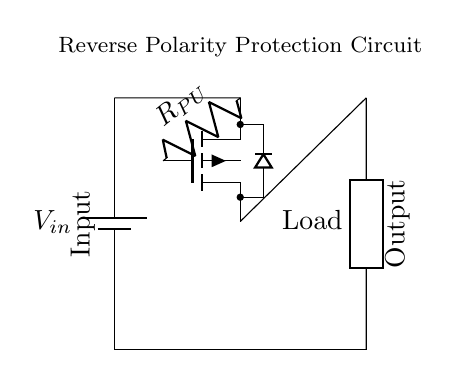What type of MOSFET is used in this circuit? The circuit diagram contains a P-channel MOSFET as indicated by the symbol shown, which has the gate labeled and is connected from the source to the load.
Answer: P-channel MOSFET What does the resistor in the circuit represent? The resistor labeled R_PU is a pull-up resistor used to ensure that the MOSFET is turned off when V_in is at or near zero volts, preventing undesired operation of the circuit.
Answer: Pull-up resistor What is the function of this reverse polarity protection circuit? The circuit protects the load from being damaged by reverse polarity conditions by using the P-channel MOSFET to block the current when the voltage is reversed.
Answer: Protects against reverse polarity What is the configuration of the load in the circuit? The load is represented as a generic component connected to the output of the P-channel MOSFET, effectively receiving power when the MOSFET is conducting.
Answer: Generic load How does the circuit behave when V_in is negative? When V_in is negative, the P-channel MOSFET will turn off, preventing current flow to the load and protecting it from reverse polarity damage.
Answer: No current flow What happens to the P-channel MOSFET when V_in is applied correctly? When V_in is applied in the correct polarity, the gate voltage becomes lower than the source voltage, turning the P-channel MOSFET on and allowing current to flow to the load.
Answer: MOSFET turns on 